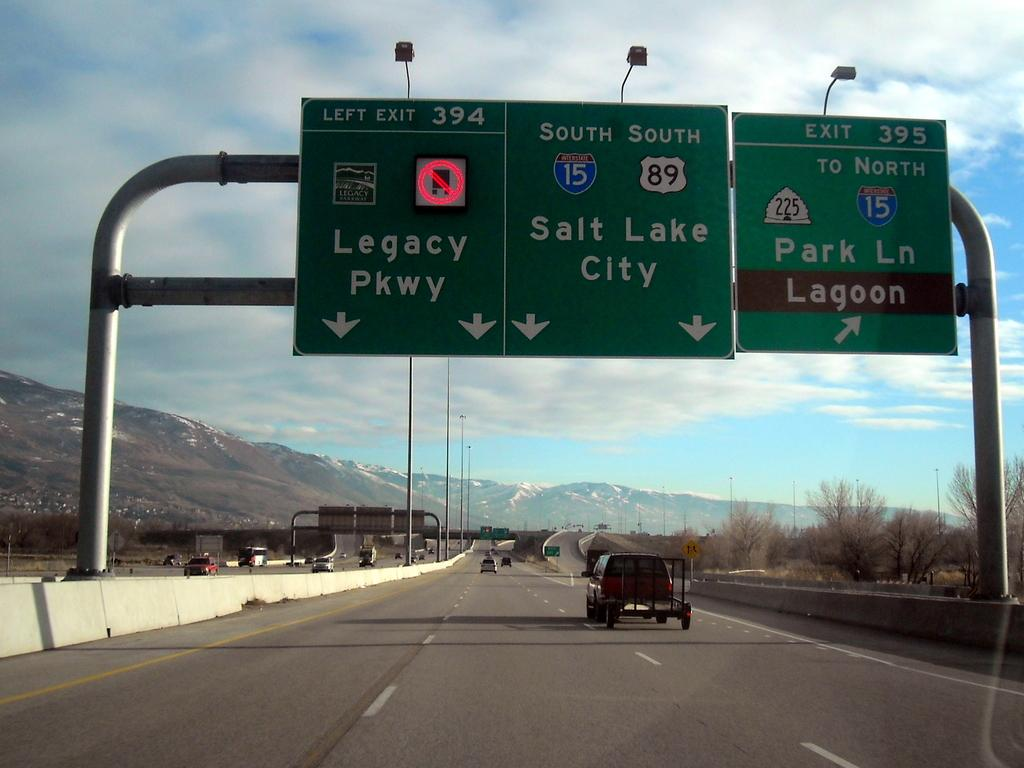<image>
Give a short and clear explanation of the subsequent image. A large green street sign indicating which lane to be in for Legacy Parkway. 